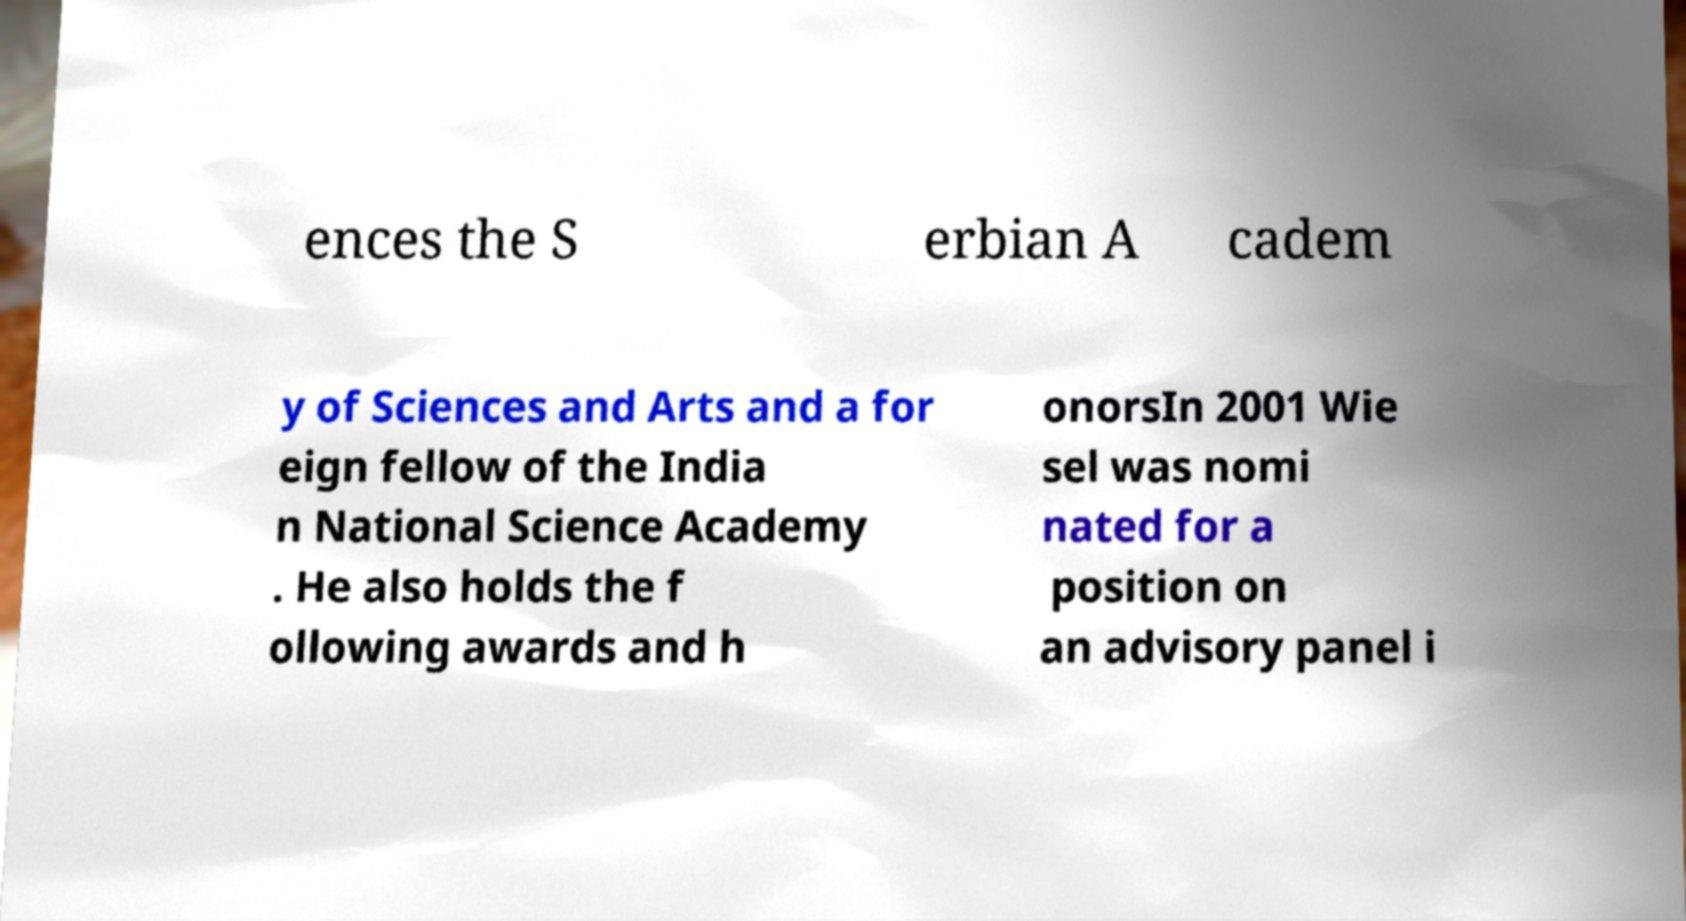Can you accurately transcribe the text from the provided image for me? ences the S erbian A cadem y of Sciences and Arts and a for eign fellow of the India n National Science Academy . He also holds the f ollowing awards and h onorsIn 2001 Wie sel was nomi nated for a position on an advisory panel i 